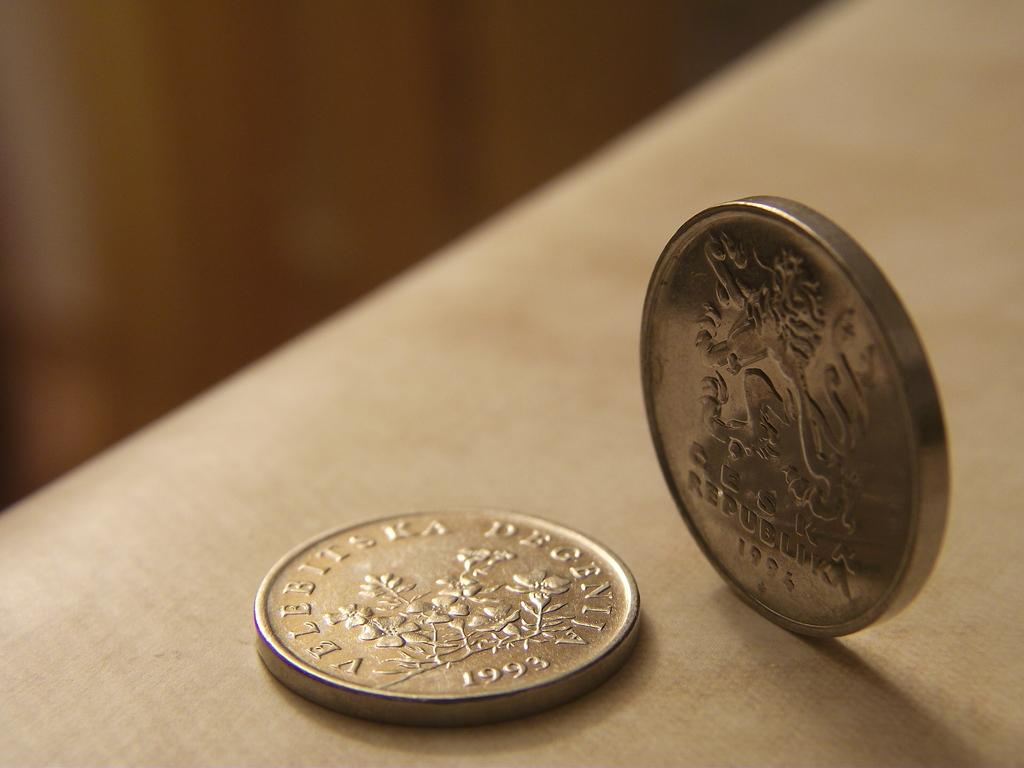<image>
Relay a brief, clear account of the picture shown. Two coins, with one placed flat that is dated 1993. 